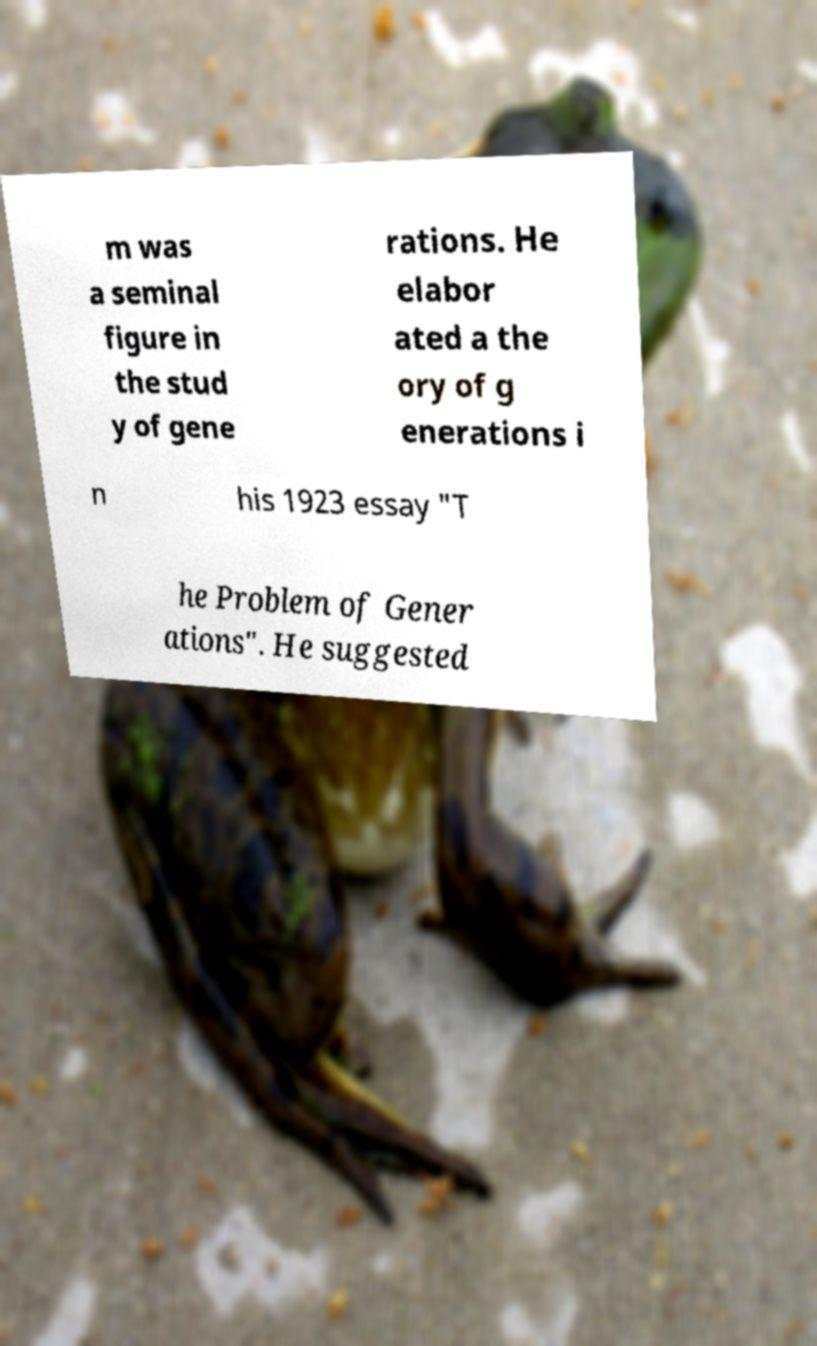Could you extract and type out the text from this image? m was a seminal figure in the stud y of gene rations. He elabor ated a the ory of g enerations i n his 1923 essay "T he Problem of Gener ations". He suggested 